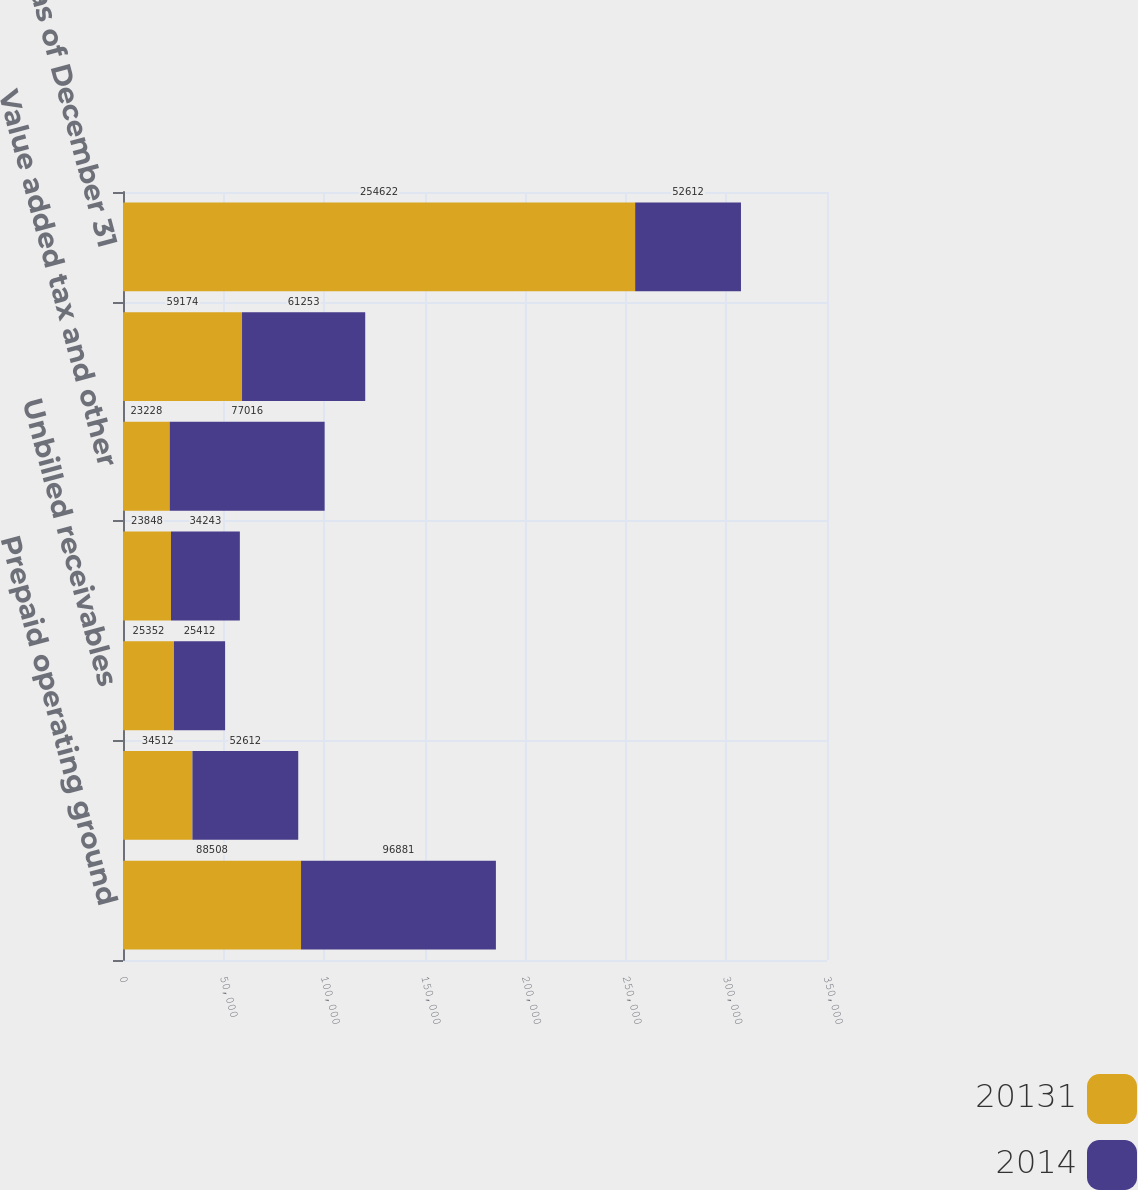Convert chart to OTSL. <chart><loc_0><loc_0><loc_500><loc_500><stacked_bar_chart><ecel><fcel>Prepaid operating ground<fcel>Prepaid income tax<fcel>Unbilled receivables<fcel>Prepaid assets<fcel>Value added tax and other<fcel>Other miscellaneous current<fcel>Balance as of December 31<nl><fcel>20131<fcel>88508<fcel>34512<fcel>25352<fcel>23848<fcel>23228<fcel>59174<fcel>254622<nl><fcel>2014<fcel>96881<fcel>52612<fcel>25412<fcel>34243<fcel>77016<fcel>61253<fcel>52612<nl></chart> 